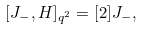Convert formula to latex. <formula><loc_0><loc_0><loc_500><loc_500>[ J _ { - } , H ] _ { q ^ { 2 } } = [ 2 ] J _ { - } ,</formula> 